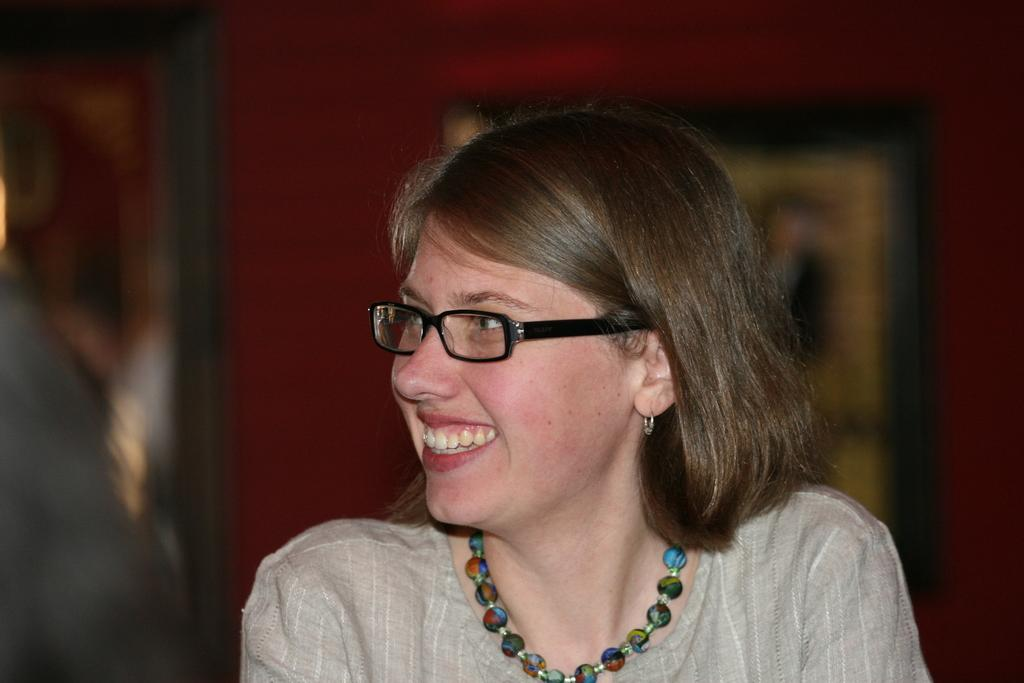Who is present in the image? There is a woman in the image. Where is the woman located in the image? The woman is at the bottom of the image. What can be seen in the background of the image? There is a wall in the background of the image. What type of dress is the bird wearing in the image? There is no bird present in the image, and therefore no dress or bird can be observed. 